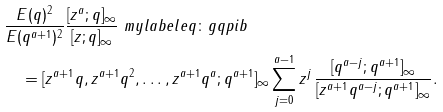Convert formula to latex. <formula><loc_0><loc_0><loc_500><loc_500>& \frac { E ( q ) ^ { 2 } } { E ( q ^ { a + 1 } ) ^ { 2 } } \frac { [ z ^ { a } ; q ] _ { \infty } } { [ z ; q ] _ { \infty } } \ m y l a b e l { e q \colon g q p i b } \\ & \quad = [ z ^ { a + 1 } q , z ^ { a + 1 } q ^ { 2 } , \dots , z ^ { a + 1 } q ^ { a } ; q ^ { a + 1 } ] _ { \infty } \sum _ { j = 0 } ^ { a - 1 } z ^ { j } \, \frac { [ q ^ { a - j } ; q ^ { a + 1 } ] _ { \infty } } { [ z ^ { a + 1 } q ^ { a - j } ; q ^ { a + 1 } ] _ { \infty } } .</formula> 